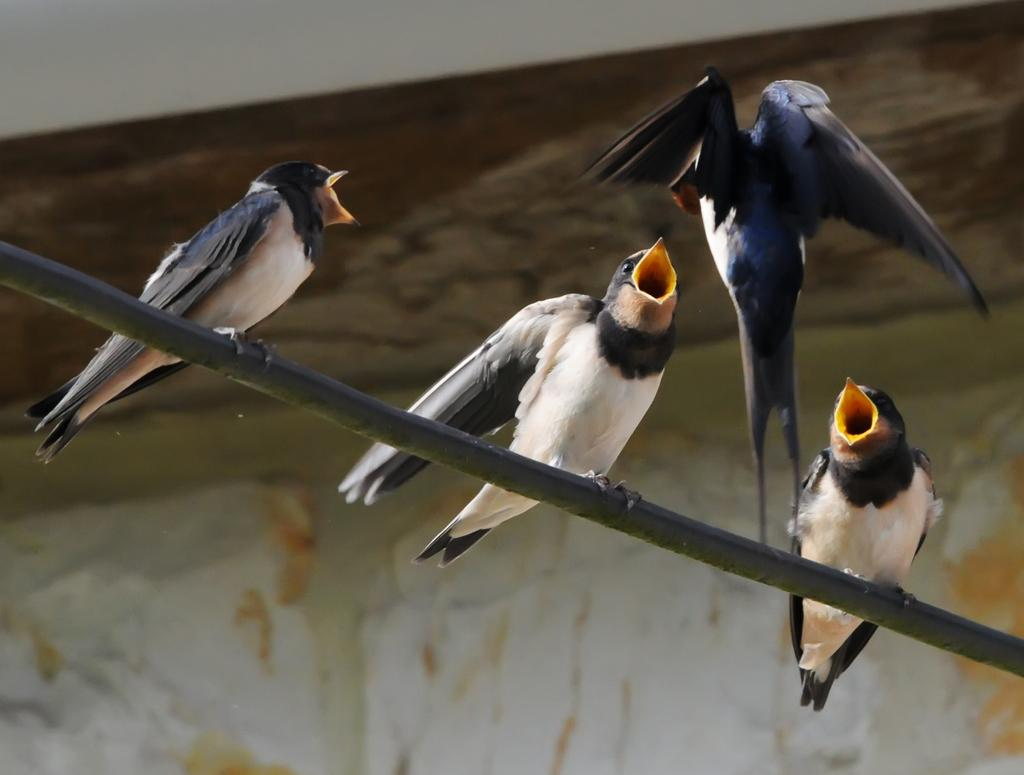What type of animals can be seen in the image? There are birds in the image. What else is present in the image besides the birds? There is an object and a wall in the image. What type of pan is hanging on the wall in the image? There is no pan present in the image; it only features birds, an object, and a wall. 